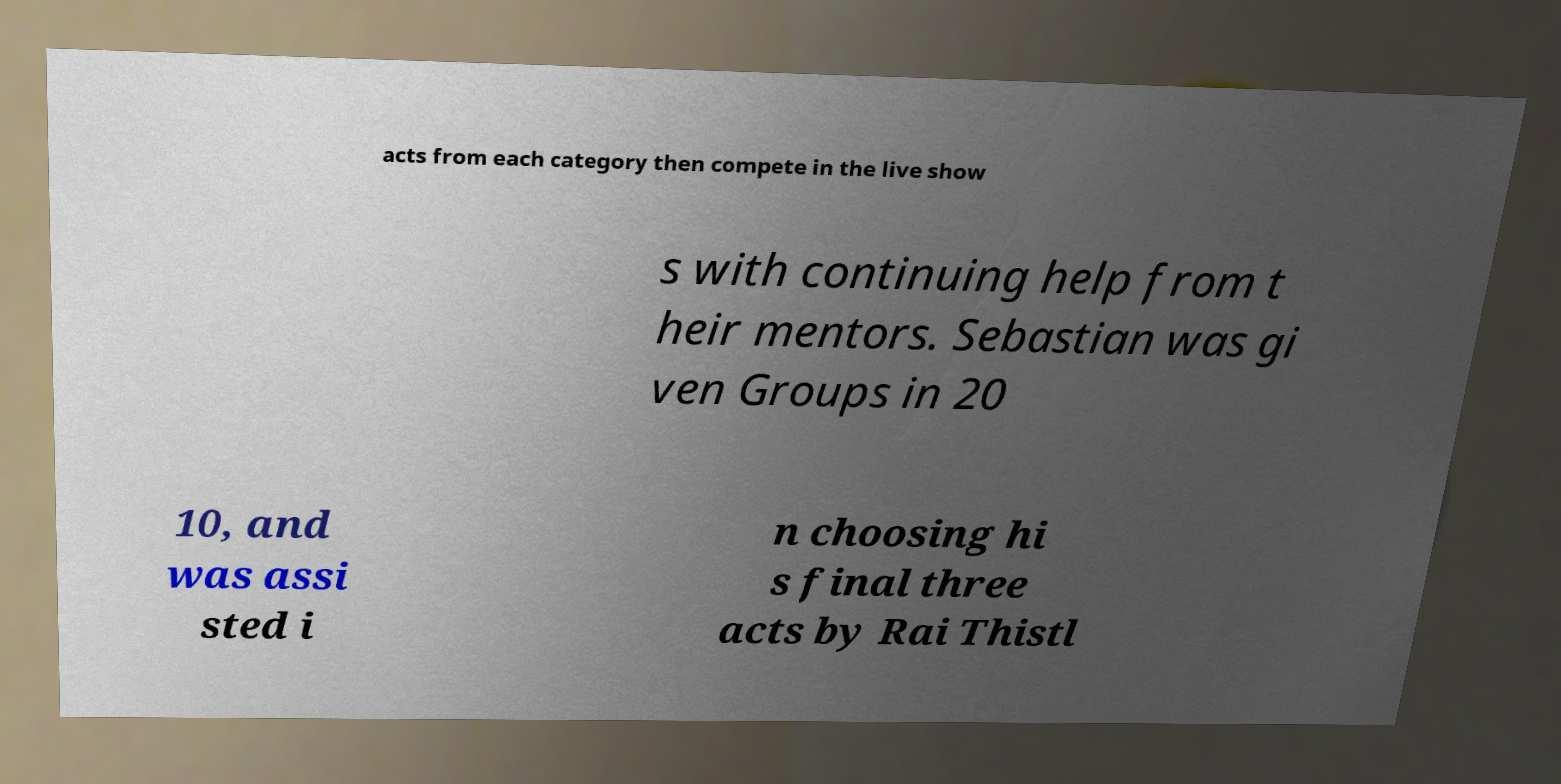I need the written content from this picture converted into text. Can you do that? acts from each category then compete in the live show s with continuing help from t heir mentors. Sebastian was gi ven Groups in 20 10, and was assi sted i n choosing hi s final three acts by Rai Thistl 